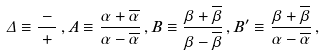<formula> <loc_0><loc_0><loc_500><loc_500>\Delta \equiv \frac { \Gamma - \overline { \Gamma } } { \Gamma + \overline { \Gamma } } \, , A \equiv \frac { \alpha + \overline { \alpha } } { \alpha - \overline { \alpha } } \, , B \equiv \frac { \beta + \overline { \beta } } { \beta - \overline { \beta } } \, , B ^ { \prime } \equiv \frac { \beta + \overline { \beta } } { \alpha - \overline { \alpha } } \, ,</formula> 